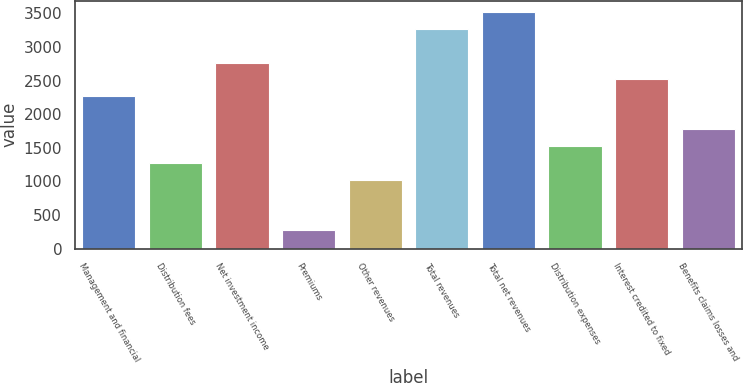Convert chart. <chart><loc_0><loc_0><loc_500><loc_500><bar_chart><fcel>Management and financial<fcel>Distribution fees<fcel>Net investment income<fcel>Premiums<fcel>Other revenues<fcel>Total revenues<fcel>Total net revenues<fcel>Distribution expenses<fcel>Interest credited to fixed<fcel>Benefits claims losses and<nl><fcel>2270.5<fcel>1276.5<fcel>2767.5<fcel>282.5<fcel>1028<fcel>3264.5<fcel>3513<fcel>1525<fcel>2519<fcel>1773.5<nl></chart> 